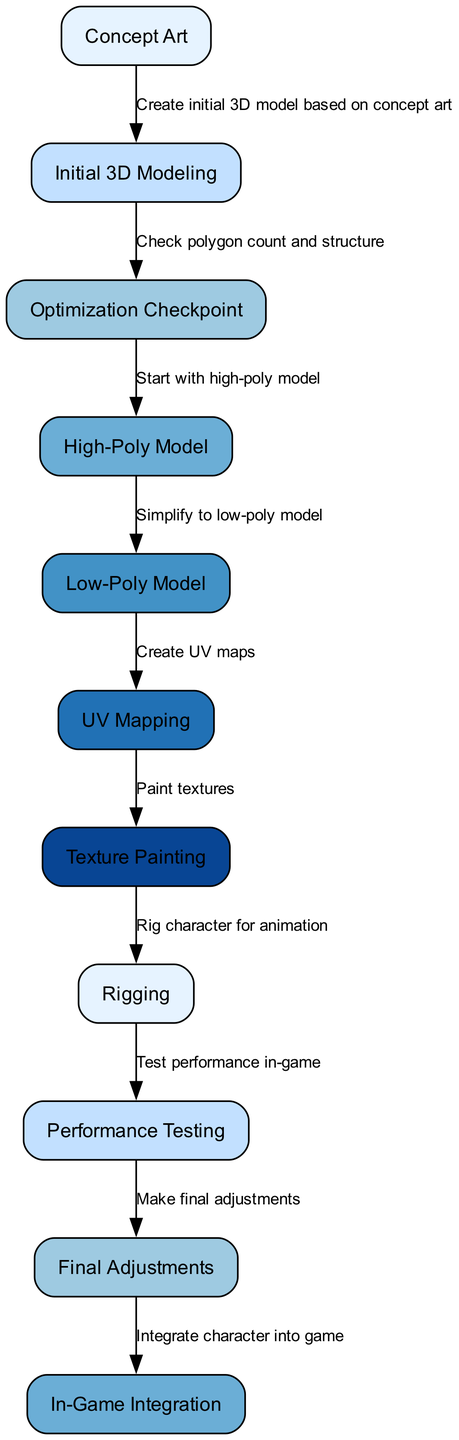What is the first step in the character design workflow? The first step in the workflow is labeled as "Concept Art". This is indicated as the starting point in the diagram with an arrow pointing to the next step.
Answer: Concept Art How many nodes are present in the diagram? By counting the nodes listed, there are a total of eleven nodes in the diagram, as indicated by the various steps from concept art to in-game integration.
Answer: 11 Which node follows the "Texture Painting" step? The node that follows "Texture Painting" is labeled "Rigging". This is determined by observing the arrows in the diagram which show the flow from one step to another.
Answer: Rigging What key optimization check is performed after the "Initial 3D Modeling"? The optimization check labeled in the diagram is to "Check polygon count and structure". This step follows immediately after the initial 3D modeling node according to the arrows connecting them.
Answer: Check polygon count and structure What is the output after the "Simplify to low-poly model" step? The output following "Simplify to low-poly model" is that the workflow moves to "Create UV maps", as indicated by the connecting arrow pointing towards that node.
Answer: Create UV maps What is the final step of the character design workflow? The final step in the workflow is labeled "In-Game Integration", which is the last node in the sequence showing how the character is integrated into the game after all prior steps.
Answer: In-Game Integration What is the relationship between "High-Poly Model" and "Low-Poly Model"? The relationship is that the "High-Poly Model" step leads to the "Low-Poly Model" step. This is indicated by the arrow directing from the high-poly node to the low-poly node in the workflow diagram.
Answer: High-Poly Model to Low-Poly Model Which step precedes the "Performance Testing" phase? The step that directly precedes "Performance Testing" is "Rigging". This is determined from the diagram flow leading up to the performance testing stage.
Answer: Rigging 